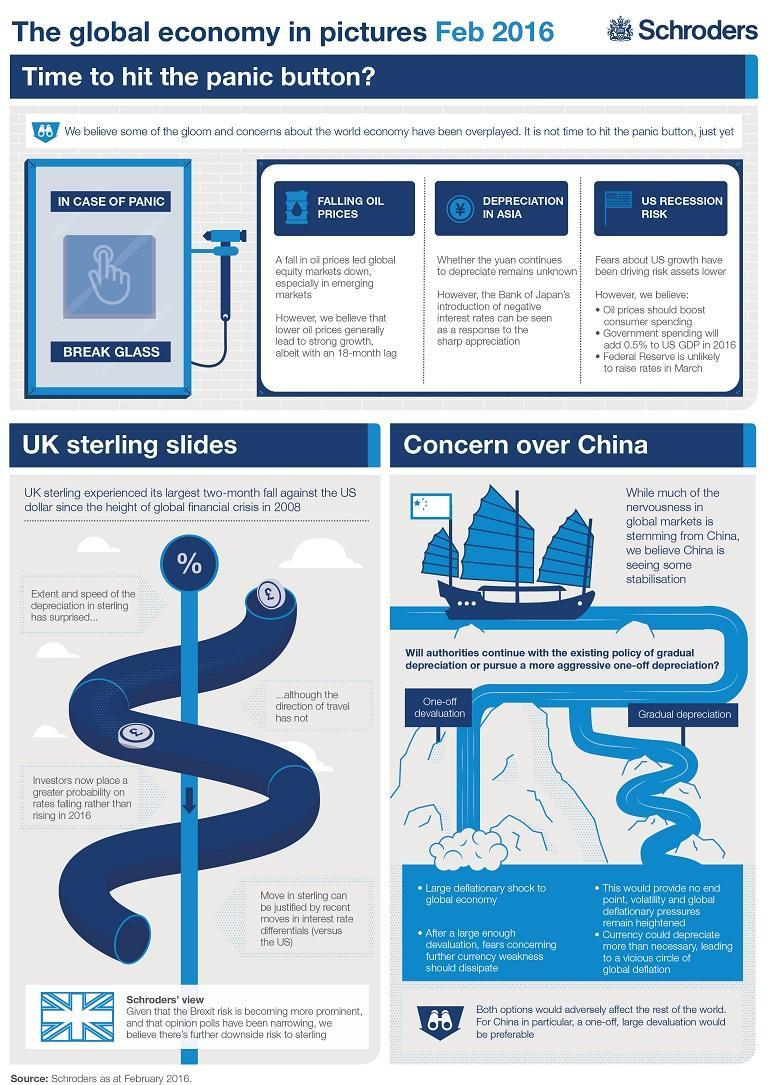Which economic policies are being considered by the authorities to stabilize markets?
Answer the question with a short phrase. One-off devaluation, Gradual depreciation How many economic trends show that the global economy is in crisis? 3 